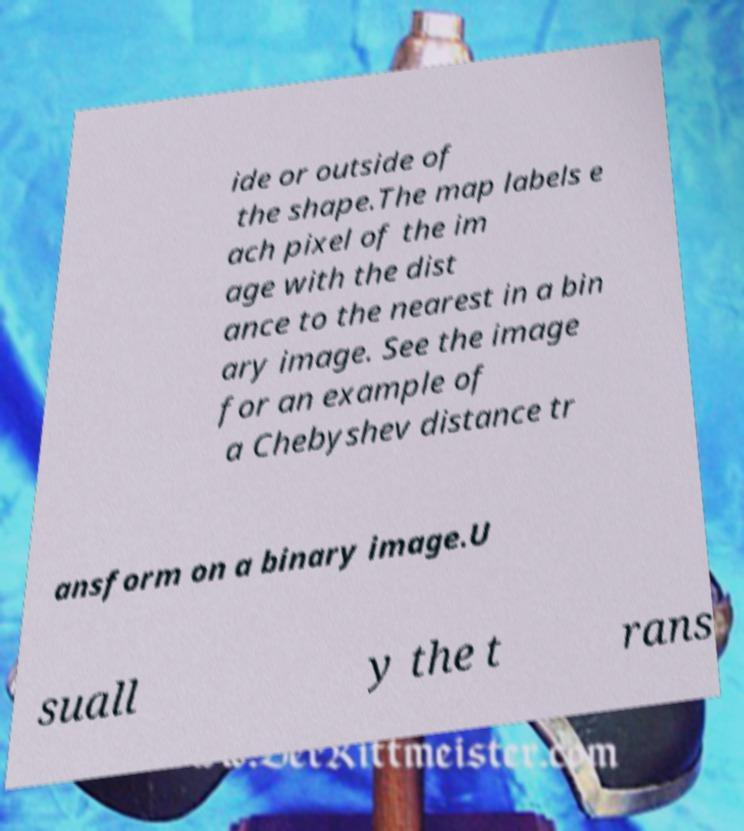Can you accurately transcribe the text from the provided image for me? ide or outside of the shape.The map labels e ach pixel of the im age with the dist ance to the nearest in a bin ary image. See the image for an example of a Chebyshev distance tr ansform on a binary image.U suall y the t rans 